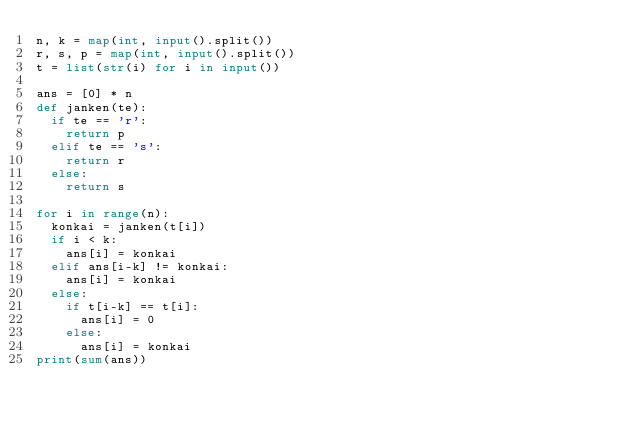<code> <loc_0><loc_0><loc_500><loc_500><_Python_>n, k = map(int, input().split())
r, s, p = map(int, input().split())
t = list(str(i) for i in input())

ans = [0] * n
def janken(te):
  if te == 'r':
    return p
  elif te == 's':
    return r
  else:
    return s
    
for i in range(n):
  konkai = janken(t[i])
  if i < k:
    ans[i] = konkai
  elif ans[i-k] != konkai:
    ans[i] = konkai
  else:
    if t[i-k] == t[i]:
      ans[i] = 0
    else:
      ans[i] = konkai
print(sum(ans))</code> 